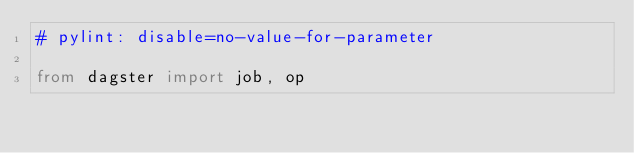Convert code to text. <code><loc_0><loc_0><loc_500><loc_500><_Python_># pylint: disable=no-value-for-parameter

from dagster import job, op</code> 